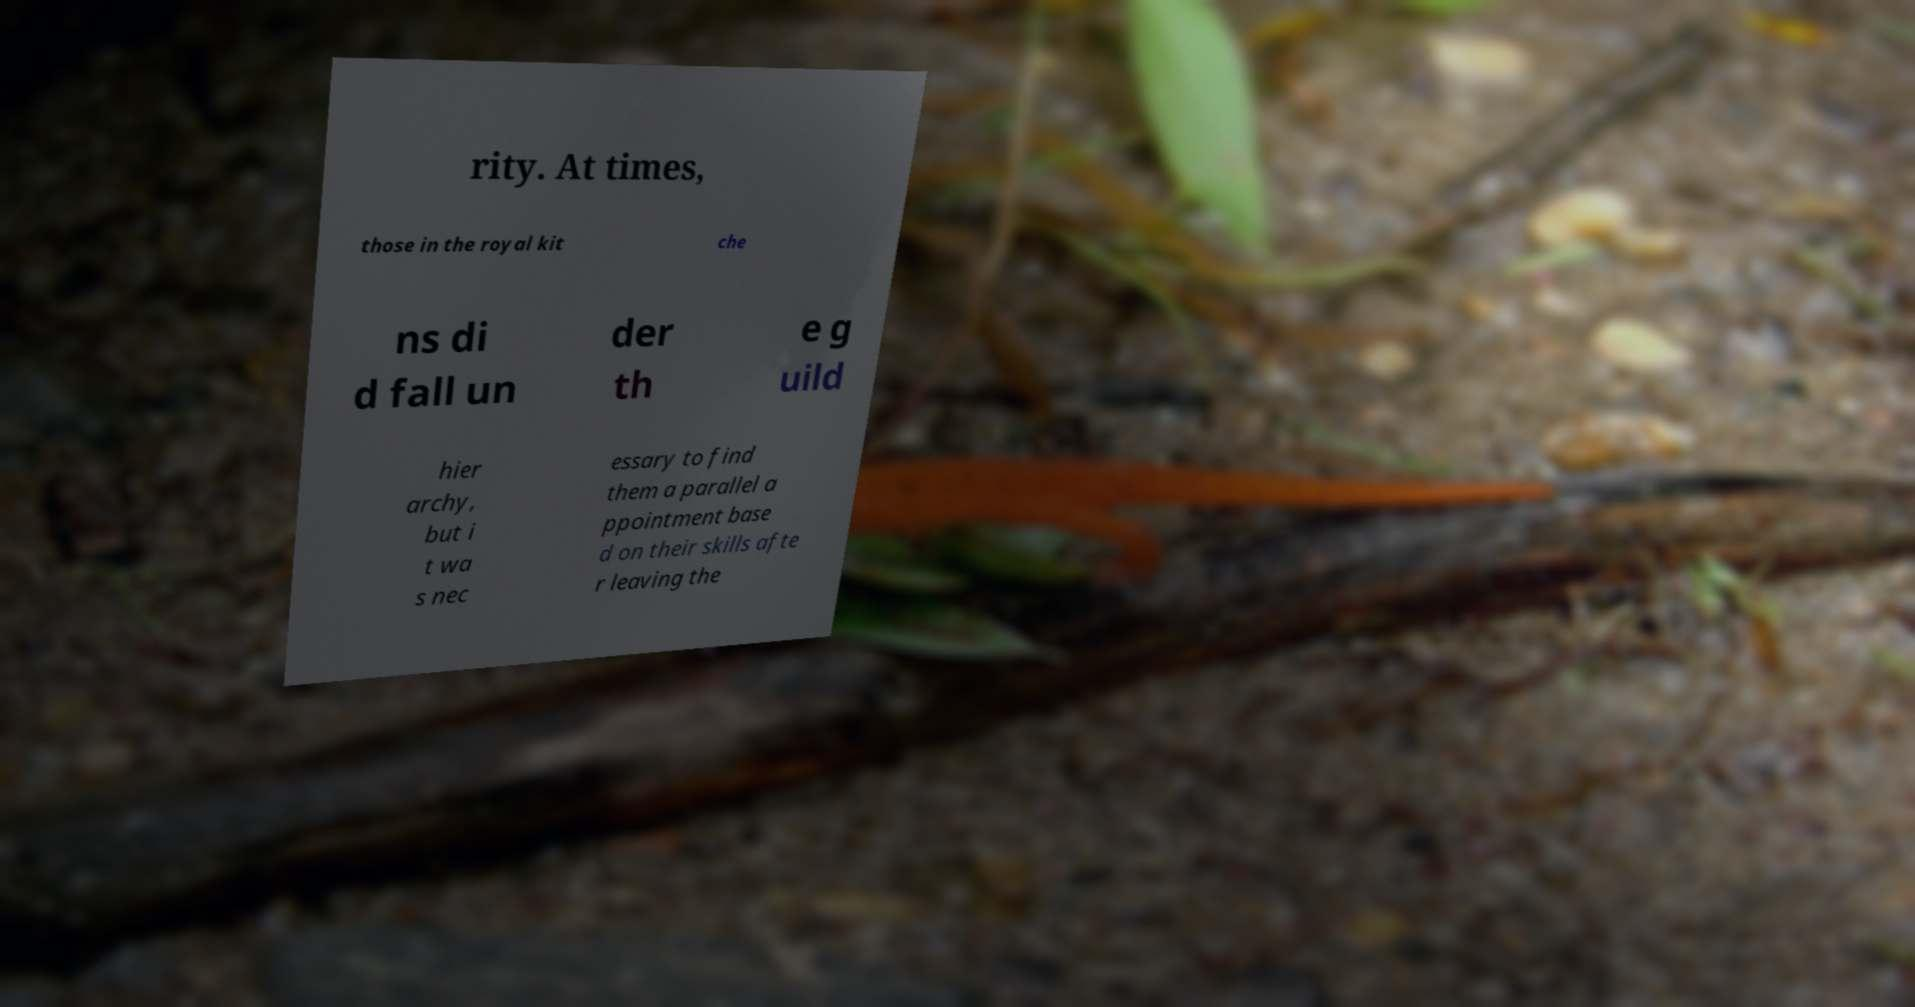Could you extract and type out the text from this image? rity. At times, those in the royal kit che ns di d fall un der th e g uild hier archy, but i t wa s nec essary to find them a parallel a ppointment base d on their skills afte r leaving the 